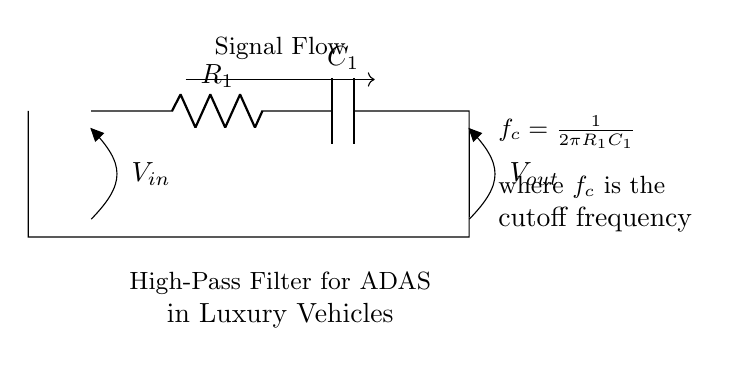What type of filter is shown in the diagram? The circuit represents a high-pass filter, which allows high-frequency signals to pass through while attenuating low-frequency signals. The label in the diagram explicitly states "High-Pass Filter for ADAS in Luxury Vehicles."
Answer: High-pass filter What is the governing formula for the cutoff frequency? The cutoff frequency formula is provided in the diagram as \( f_c = \frac{1}{2\pi R_1C_1} \). This indicates how the cutoff frequency depends on the resistance \( R_1 \) and capacitance \( C_1 \).
Answer: f_c = 1/(2πR_1C_1) Which components are present in this circuit? The circuit diagram includes a resistor \( R_1 \) and a capacitor \( C_1 \). These two components are essential for creating the high-pass filter effect.
Answer: Resistor and capacitor What is the role of the resistor in the circuit? The resistor \( R_1 \) limits current flow and affects the time constant of the filter. It works in conjunction with the capacitor to determine the cutoff frequency.
Answer: Limits current flow How does the high-pass characteristic affect signal frequencies? A high-pass filter allows frequencies above a certain cutoff to pass through while reducing the amplitude of frequencies lower than this cutoff frequency. Thus, the design is beneficial for signals like those in advanced driver assistance systems that may contain higher-frequency data.
Answer: It allows high frequencies to pass What is connected to the output in this configuration? The output voltage \( V_{out} \) is taken across the capacitor \( C_1 \) in this configuration, which will represent the filtered high-frequency signal.
Answer: Capacitor \( C_1 \) What is the significance of the cutoff frequency in ADAS applications? The cutoff frequency is critical in ensuring that only the necessary high-frequency signals, which are often more informative for Advanced Driver Assistance Systems, are processed and sent through for further handling. This is crucial for the performance and reliability of safety features in luxury vehicles.
Answer: Essential for signal filtering 